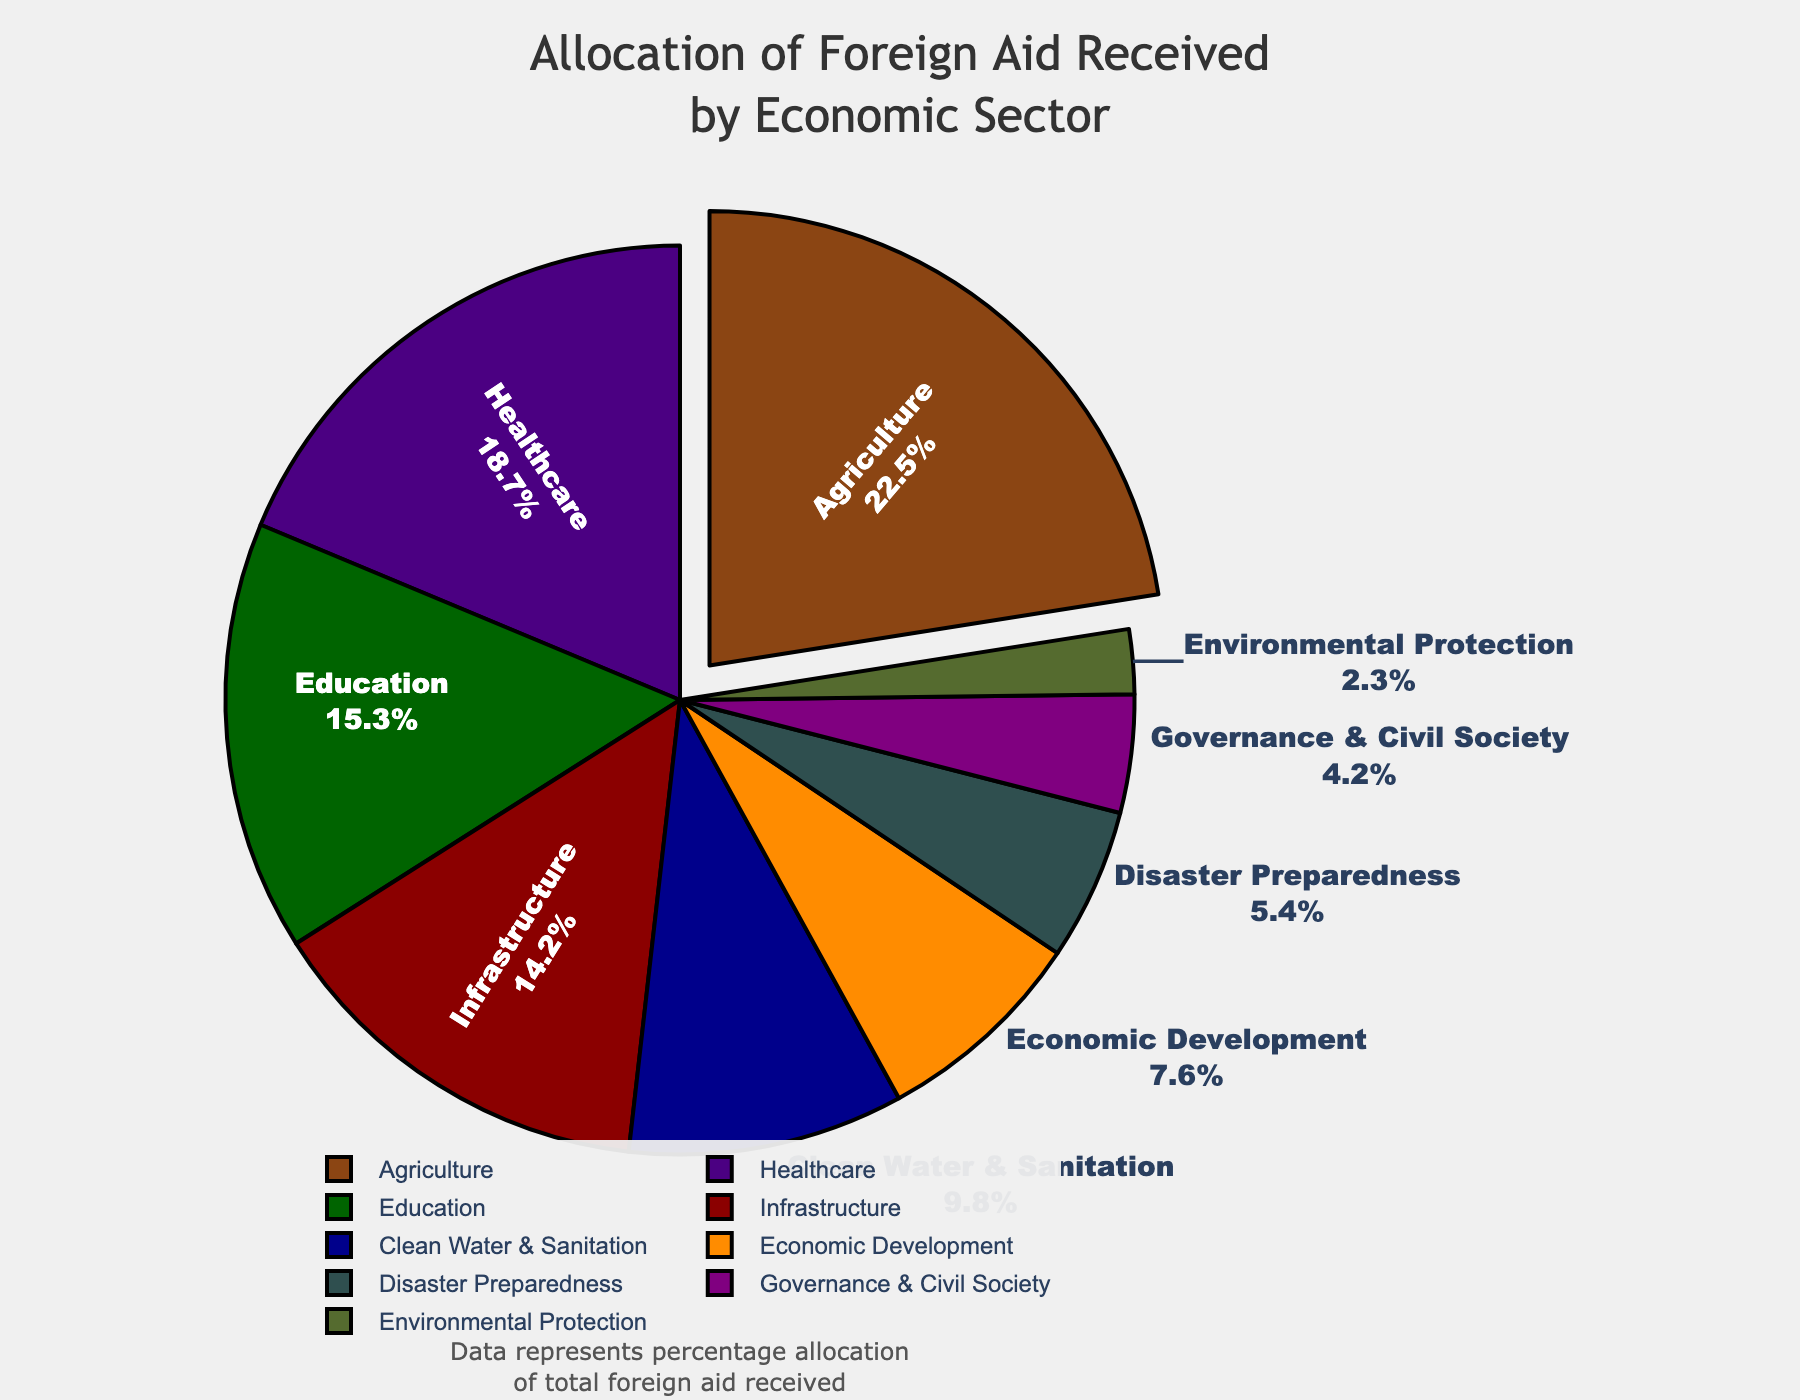Which sector receives the highest allocation of foreign aid? By looking at the pie chart, we see that the sector with the largest portion of the pie, which is pulled out a bit from the chart for emphasis, is Agriculture.
Answer: Agriculture Which two sectors combined receive less than the allocation for Agriculture? Agriculture receives 22.5%. The two smallest sectors on the chart are Environmental Protection (2.3%) and Governance & Civil Society (4.2%). Their combined allocation is 2.3% + 4.2% = 6.5%, which is less than 22.5%.
Answer: Environmental Protection and Governance & Civil Society How does the allocation to Infrastructure compare to Healthcare? By examining the size of the segments, Healthcare has an allocation of 18.7%, whereas Infrastructure has 14.2%. Therefore, Healthcare receives more allocation than Infrastructure.
Answer: Healthcare receives more than Infrastructure What is the total percentage allocated to Disaster Preparedness and Clean Water & Sanitation? Disaster Preparedness receives 5.4% and Clean Water & Sanitation receives 9.8%. Adding these percentages gives 5.4% + 9.8% = 15.2%.
Answer: 15.2% Which sector has a greater allocation: Economic Development or Education? By comparing their segments, Economic Development has 7.6% while Education has 15.3%. Education has a greater allocation than Economic Development.
Answer: Education What is the total percentage allocated to sectors with a green color or related shade? Examining the colors, the green-related sectors are Agriculture (22.5%) and Environmental Protection (2.3%). Adding these gives 22.5% + 2.3% = 24.8%.
Answer: 24.8% Which sector receives the smallest allocation, and what is that percentage? By identifying the smallest segment on the pie chart, Environmental Protection is the smallest, receiving 2.3% of the total allocation.
Answer: Environmental Protection, 2.3% How does the allocation to Education and Clean Water & Sanitation compare to Infrastructure and Governance & Civil Society combined? Education has 15.3% and Clean Water & Sanitation has 9.8%, totaling 15.3% + 9.8% = 25.1%. Infrastructure has 14.2% and Governance & Civil Society has 4.2%, totaling 14.2% + 4.2% = 18.4%. Comparing these sums, 25.1% is greater than 18.4%.
Answer: Education and Clean Water & Sanitation receive more than Infrastructure and Governance & Civil Society What percentage of the total allocation goes towards sectors related to economic improvement, including both Economic Development and Infrastructure? Economic Development has 7.6%, and Infrastructure has 14.2%. Adding these gives 7.6% + 14.2% = 21.8%.
Answer: 21.8% What is the difference in allocation between Agriculture and Healthcare? Agriculture receives 22.5%, while Healthcare receives 18.7%. The difference is 22.5% - 18.7% = 3.8%.
Answer: 3.8% 